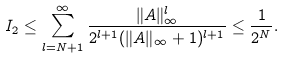Convert formula to latex. <formula><loc_0><loc_0><loc_500><loc_500>I _ { 2 } \leq \sum _ { l = N + 1 } ^ { \infty } \frac { \| A \| _ { \infty } ^ { l } } { 2 ^ { l + 1 } ( \| A \| _ { \infty } + 1 ) ^ { l + 1 } } \leq \frac { 1 } { 2 ^ { N } } .</formula> 